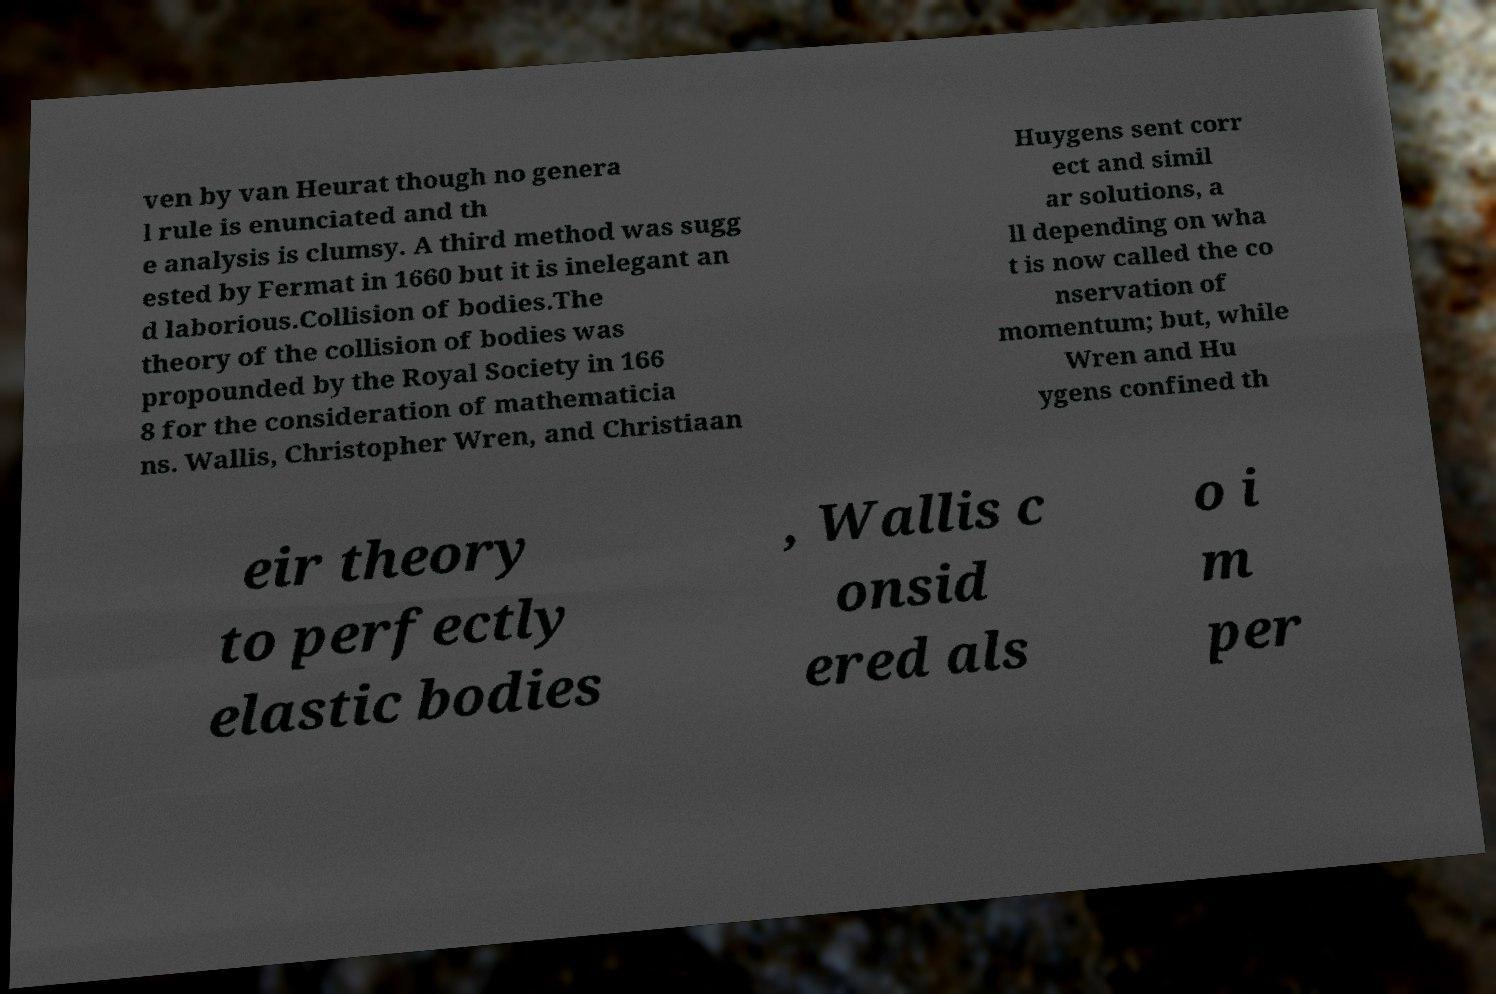Can you read and provide the text displayed in the image?This photo seems to have some interesting text. Can you extract and type it out for me? ven by van Heurat though no genera l rule is enunciated and th e analysis is clumsy. A third method was sugg ested by Fermat in 1660 but it is inelegant an d laborious.Collision of bodies.The theory of the collision of bodies was propounded by the Royal Society in 166 8 for the consideration of mathematicia ns. Wallis, Christopher Wren, and Christiaan Huygens sent corr ect and simil ar solutions, a ll depending on wha t is now called the co nservation of momentum; but, while Wren and Hu ygens confined th eir theory to perfectly elastic bodies , Wallis c onsid ered als o i m per 